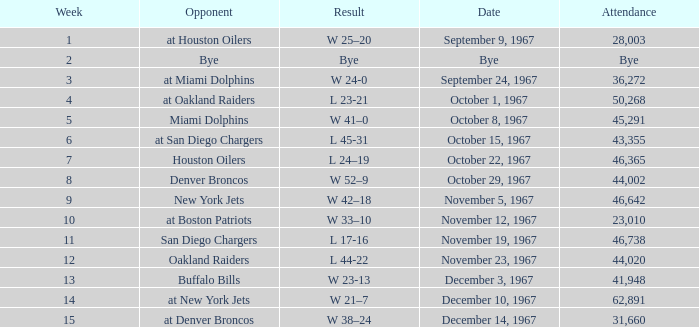What was the date of the game after week 5 against the Houston Oilers? October 22, 1967. 